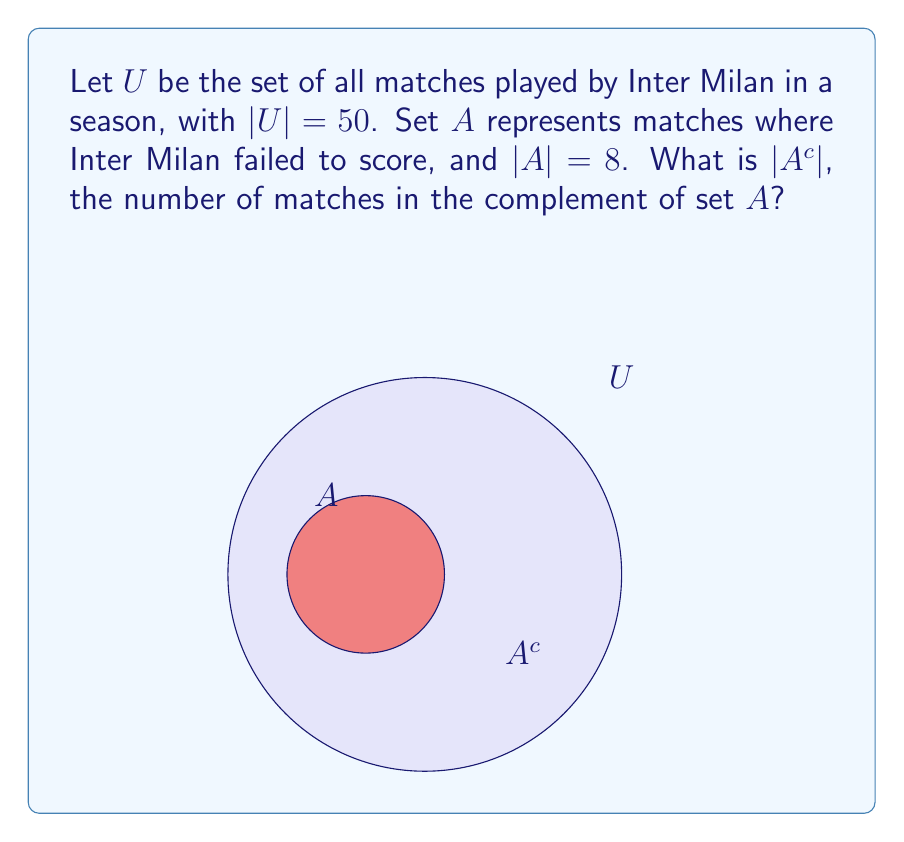Solve this math problem. To find the complement of set $A$, we need to follow these steps:

1) First, recall that the complement of a set $A$, denoted as $A^c$, contains all elements in the universal set $U$ that are not in $A$.

2) We know that:
   - $|U|$ = 50 (total number of matches)
   - $|A|$ = 8 (matches where Inter Milan failed to score)

3) The fundamental relationship between a set and its complement is:
   $$|U| = |A| + |A^c|$$

4) We can rearrange this equation to solve for $|A^c|$:
   $$|A^c| = |U| - |A|$$

5) Substituting the known values:
   $$|A^c| = 50 - 8 = 42$$

Therefore, there are 42 matches in the complement of set $A$, which represents the number of matches where Inter Milan scored at least one goal.
Answer: $|A^c| = 42$ 